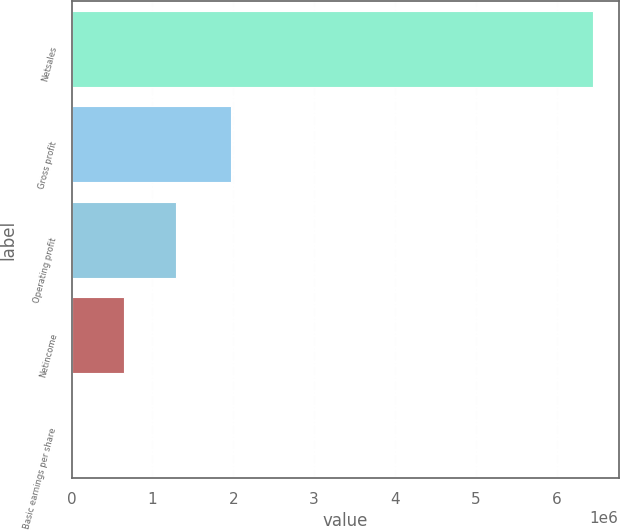Convert chart to OTSL. <chart><loc_0><loc_0><loc_500><loc_500><bar_chart><fcel>Netsales<fcel>Gross profit<fcel>Operating profit<fcel>Netincome<fcel>Basic earnings per share<nl><fcel>6.44331e+06<fcel>1.97487e+06<fcel>1.28866e+06<fcel>644332<fcel>1.53<nl></chart> 